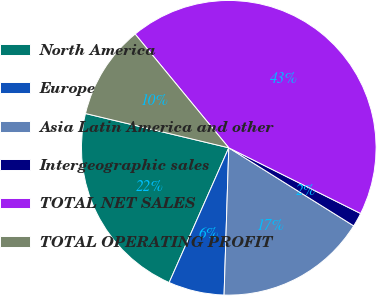Convert chart to OTSL. <chart><loc_0><loc_0><loc_500><loc_500><pie_chart><fcel>North America<fcel>Europe<fcel>Asia Latin America and other<fcel>Intergeographic sales<fcel>TOTAL NET SALES<fcel>TOTAL OPERATING PROFIT<nl><fcel>22.11%<fcel>6.12%<fcel>16.62%<fcel>1.53%<fcel>43.32%<fcel>10.3%<nl></chart> 